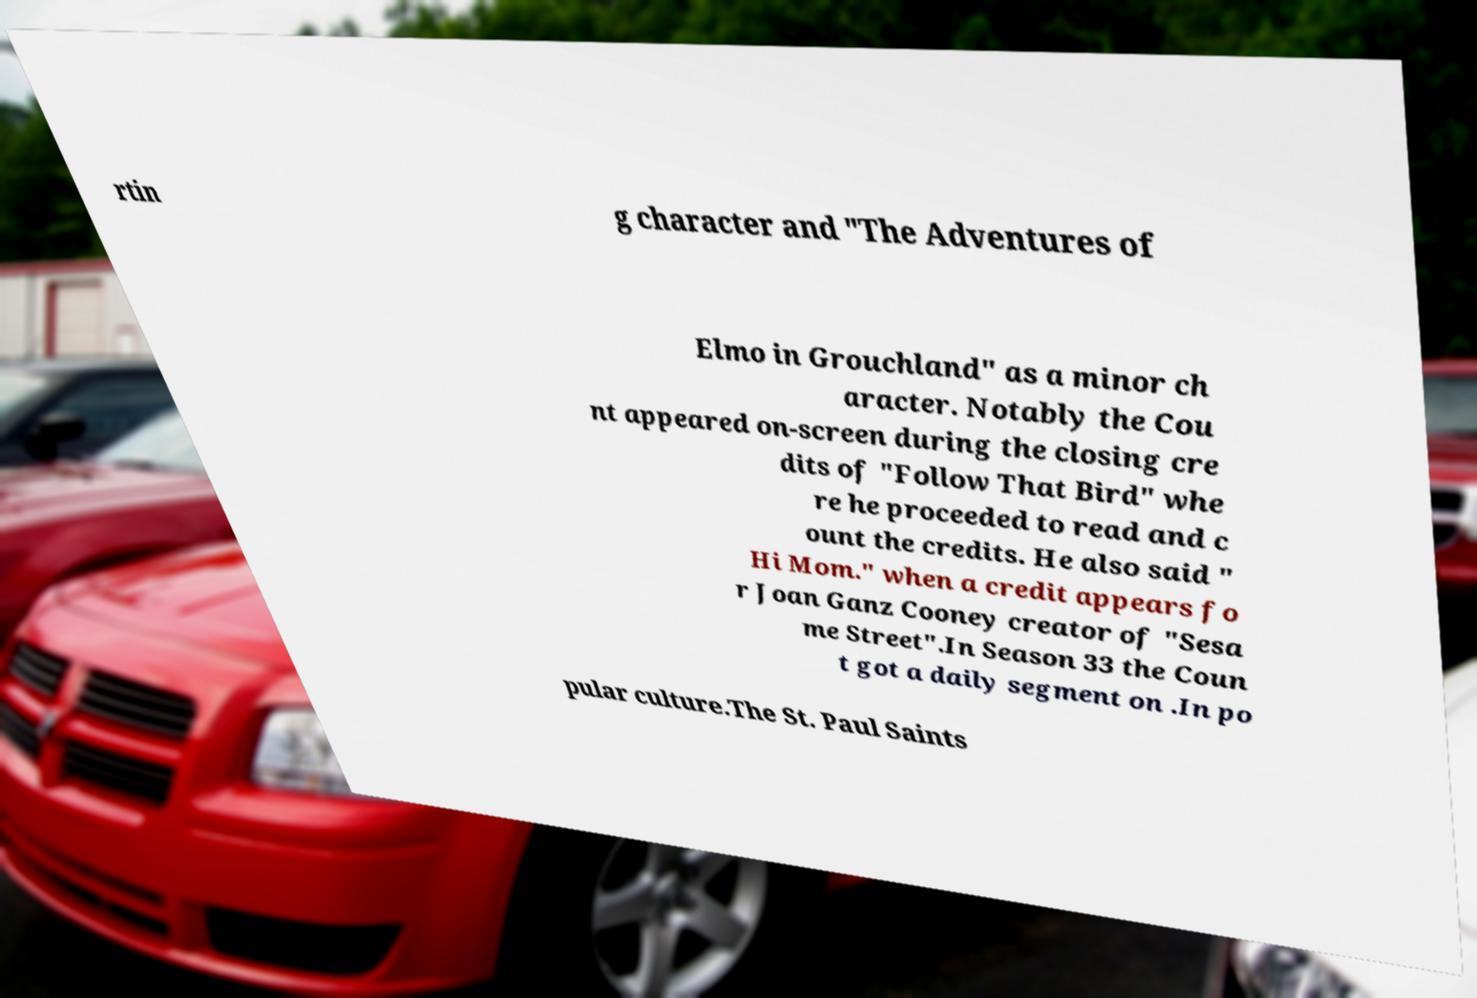What messages or text are displayed in this image? I need them in a readable, typed format. rtin g character and "The Adventures of Elmo in Grouchland" as a minor ch aracter. Notably the Cou nt appeared on-screen during the closing cre dits of "Follow That Bird" whe re he proceeded to read and c ount the credits. He also said " Hi Mom." when a credit appears fo r Joan Ganz Cooney creator of "Sesa me Street".In Season 33 the Coun t got a daily segment on .In po pular culture.The St. Paul Saints 